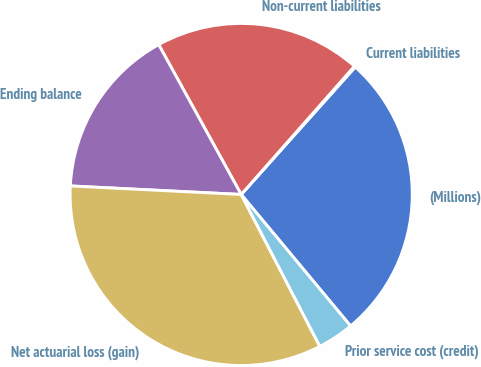Convert chart. <chart><loc_0><loc_0><loc_500><loc_500><pie_chart><fcel>(Millions)<fcel>Current liabilities<fcel>Non-current liabilities<fcel>Ending balance<fcel>Net actuarial loss (gain)<fcel>Prior service cost (credit)<nl><fcel>27.34%<fcel>0.11%<fcel>19.52%<fcel>16.2%<fcel>33.4%<fcel>3.44%<nl></chart> 